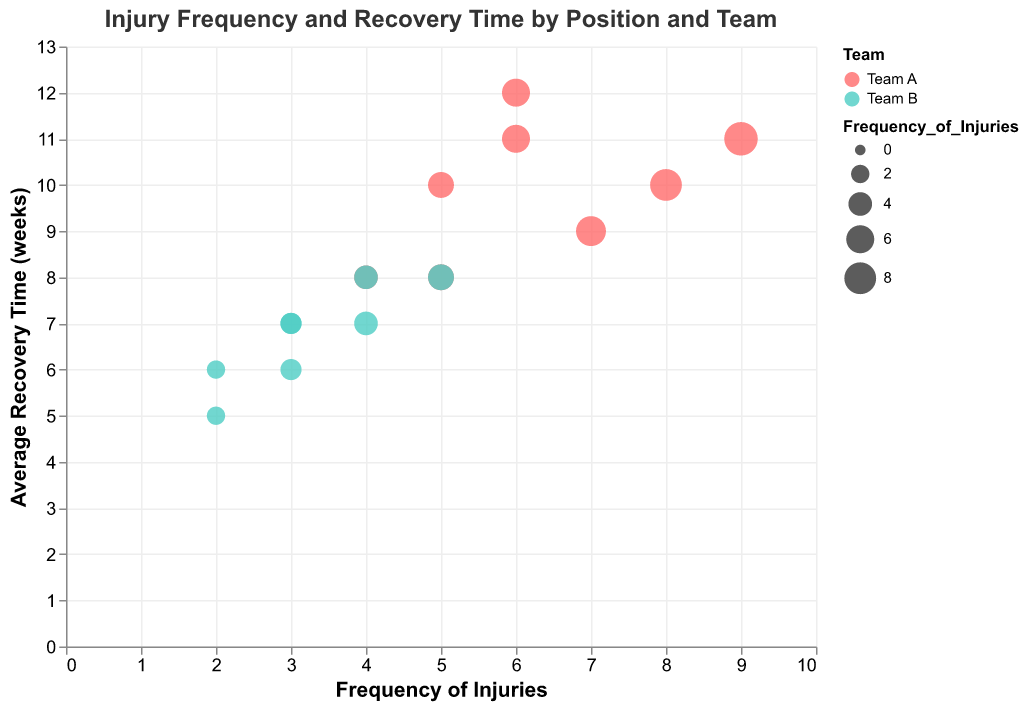How many positional data points are shown for Team A? There are 8 positions listed in the data (Quarterback, Running Back, Wide Receiver, Linebacker, Cornerback, Tight End, Offensive Lineman, Defensive Lineman), and each one has a data point for Team A. Counting these, there are 8 data points for Team A.
Answer: 8 What is the average recovery time for the Quarterbacks of both teams combined? For Team A, the Quarterback has an average recovery time of 8 weeks; for Team B, it is 6 weeks. The combined average recovery time is (8 + 6) / 2 = 7 weeks.
Answer: 7 weeks Which position has the highest frequency of injuries for Team B? By examining the bubble chart, the position with the largest bubble for Team B (highlighted in a distinct color) is the Wide Receiver with a frequency of 5 injuries.
Answer: Wide Receiver Which team has a higher average recovery time for Running Backs, and what is the difference? Team A’s Running Backs have an average recovery time of 10 weeks, and Team B’s Running Backs have 7 weeks. Team A has a higher average recovery time. The difference is 10 - 7 = 3 weeks.
Answer: Team A, 3 weeks For which position does Team A have a significantly higher frequency of injuries compared to Team B? The positions with the largest differences in bubble sizes (frequency of injuries) between the two teams can be observed. The Linebacker stands out with Team A having 6 injuries compared to Team B’s 2 injuries.
Answer: Linebacker Which team generally has lower average recovery times and how can you tell? By examining the y-axis values of the corresponding colors for both teams, it is evident that Team B generally has lower average recovery times across most positions, shown by their positions being generally lower on the y-axis.
Answer: Team B What pattern do you observe about the injury frequency and average recovery time relationship for Team A? For Team A, positions with a higher frequency of injuries generally also have higher average recovery times, as indicated by the upward trend of bubbles for that team on the chart.
Answer: Higher injury frequency leads to higher recovery time Which position for Team B has the smallest bubble and what does it signify? The smallest bubble for Team B corresponds to the Tight End position, signifying the lowest frequency of injuries, which is 2 injuries.
Answer: Tight End, 2 injuries What is the overall trend for recovery times compared between positions for the two teams? By comparing the color-coded bubbles across various positions on the chart, it is clear that Team A generally exhibits higher recovery times compared to Team B for the most part.
Answer: Team A has higher recovery times How do frequencies of injuries for Offensive Linemen compare between the two teams? Both teams have similar frequencies of injuries for Offensive Linemen, with Team A having 5 and Team B having 3, indicating a slightly higher frequency for Team A.
Answer: Team A: 5, Team B: 3 